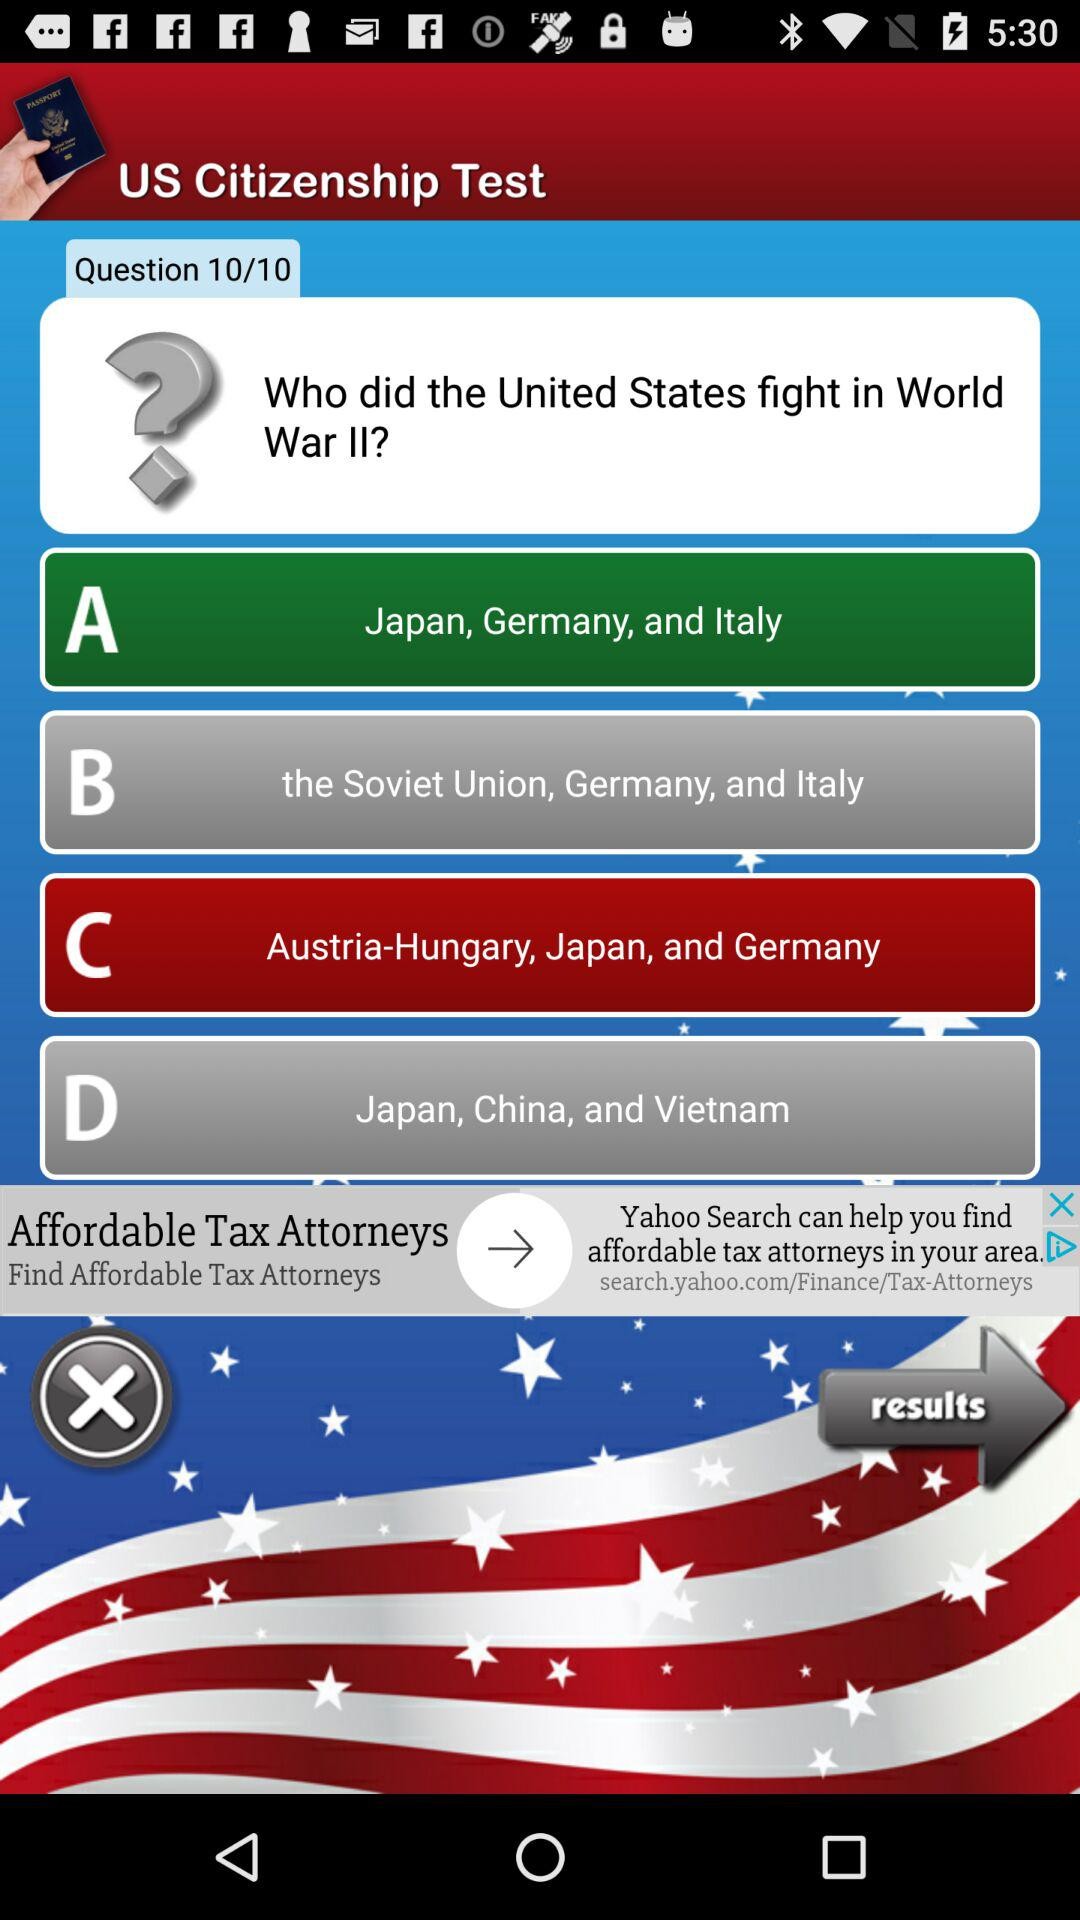What country's citizenship is the test for? The test is for US citizenship. 